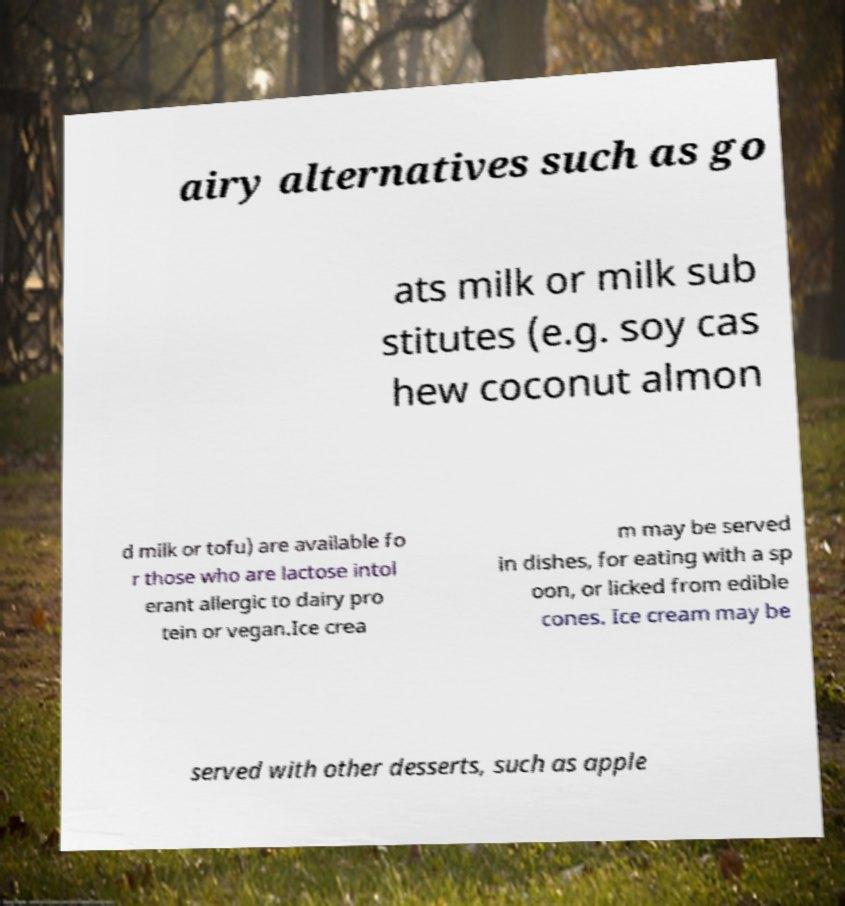Can you read and provide the text displayed in the image?This photo seems to have some interesting text. Can you extract and type it out for me? airy alternatives such as go ats milk or milk sub stitutes (e.g. soy cas hew coconut almon d milk or tofu) are available fo r those who are lactose intol erant allergic to dairy pro tein or vegan.Ice crea m may be served in dishes, for eating with a sp oon, or licked from edible cones. Ice cream may be served with other desserts, such as apple 